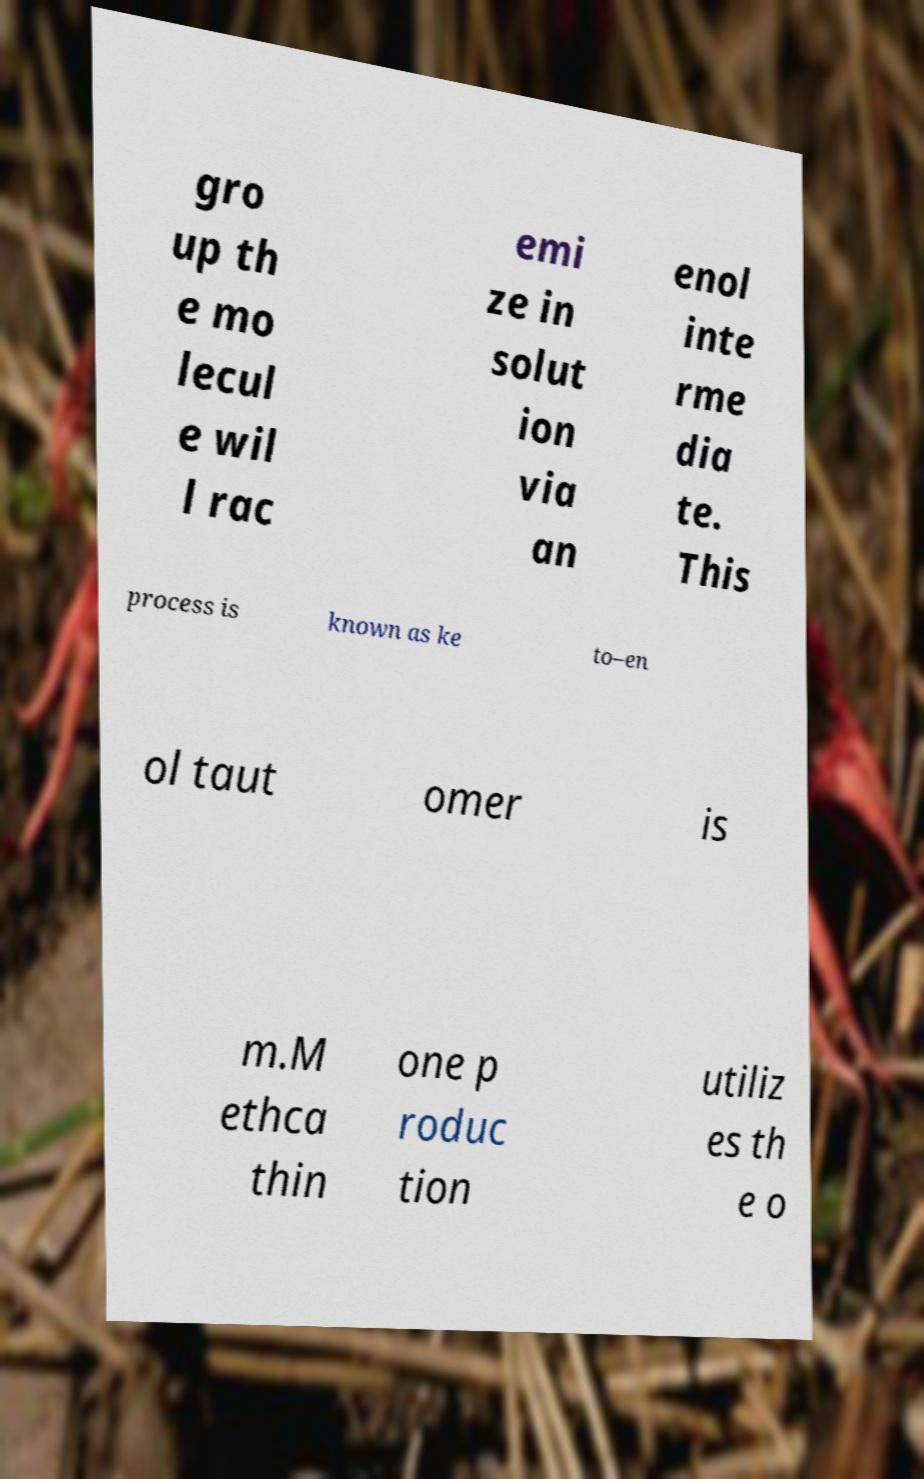Could you extract and type out the text from this image? gro up th e mo lecul e wil l rac emi ze in solut ion via an enol inte rme dia te. This process is known as ke to–en ol taut omer is m.M ethca thin one p roduc tion utiliz es th e o 